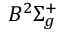Convert formula to latex. <formula><loc_0><loc_0><loc_500><loc_500>B ^ { 2 } \Sigma _ { g } ^ { + }</formula> 